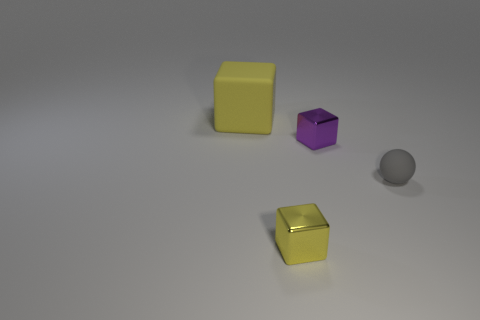Add 3 yellow metallic blocks. How many objects exist? 7 Subtract all balls. How many objects are left? 3 Add 4 tiny gray rubber spheres. How many tiny gray rubber spheres exist? 5 Subtract 0 red cubes. How many objects are left? 4 Subtract all blue balls. Subtract all tiny things. How many objects are left? 1 Add 3 small things. How many small things are left? 6 